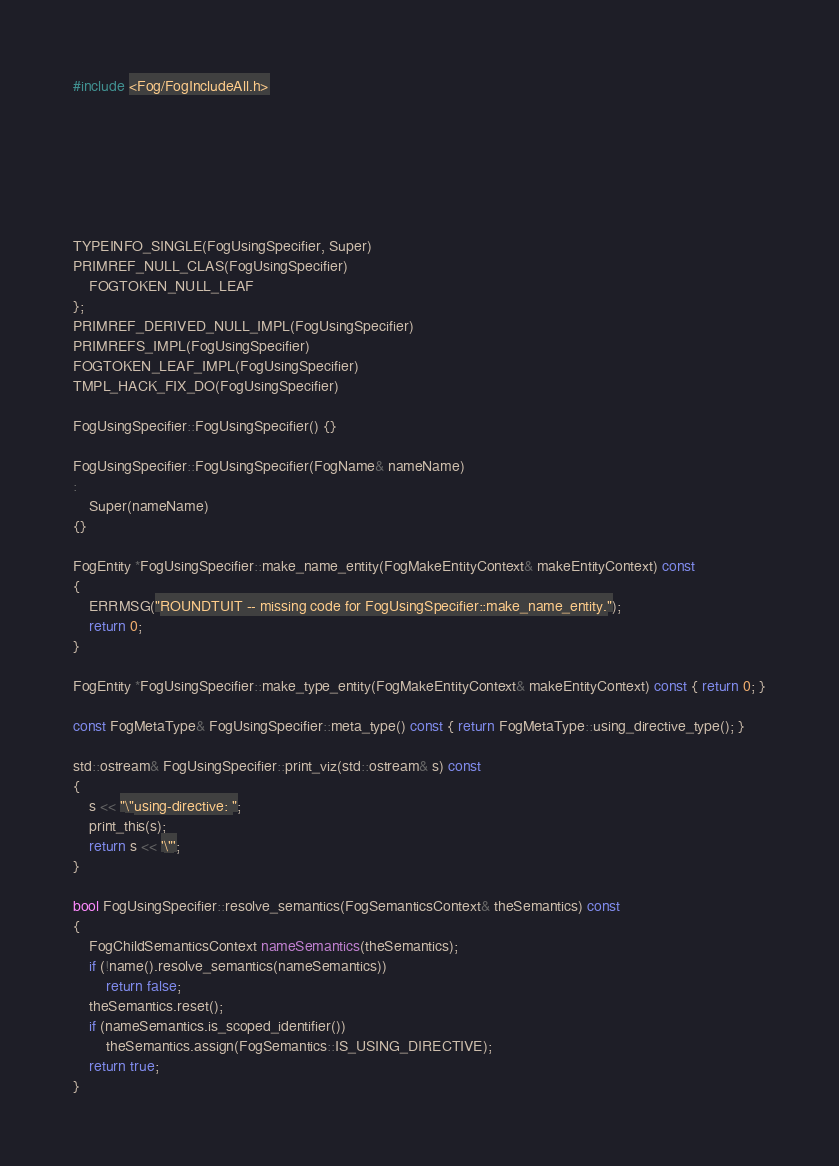Convert code to text. <code><loc_0><loc_0><loc_500><loc_500><_C++_>#include <Fog/FogIncludeAll.h>







TYPEINFO_SINGLE(FogUsingSpecifier, Super)
PRIMREF_NULL_CLAS(FogUsingSpecifier)
    FOGTOKEN_NULL_LEAF
};
PRIMREF_DERIVED_NULL_IMPL(FogUsingSpecifier)
PRIMREFS_IMPL(FogUsingSpecifier)
FOGTOKEN_LEAF_IMPL(FogUsingSpecifier)
TMPL_HACK_FIX_DO(FogUsingSpecifier)

FogUsingSpecifier::FogUsingSpecifier() {}

FogUsingSpecifier::FogUsingSpecifier(FogName& nameName)
:
    Super(nameName)
{}

FogEntity *FogUsingSpecifier::make_name_entity(FogMakeEntityContext& makeEntityContext) const
{
    ERRMSG("ROUNDTUIT -- missing code for FogUsingSpecifier::make_name_entity.");
    return 0;
}

FogEntity *FogUsingSpecifier::make_type_entity(FogMakeEntityContext& makeEntityContext) const { return 0; }

const FogMetaType& FogUsingSpecifier::meta_type() const { return FogMetaType::using_directive_type(); }

std::ostream& FogUsingSpecifier::print_viz(std::ostream& s) const
{
    s << "\"using-directive: ";
    print_this(s);
    return s << '\"';
}

bool FogUsingSpecifier::resolve_semantics(FogSemanticsContext& theSemantics) const
{
    FogChildSemanticsContext nameSemantics(theSemantics);
    if (!name().resolve_semantics(nameSemantics))
        return false;
    theSemantics.reset();
    if (nameSemantics.is_scoped_identifier())
        theSemantics.assign(FogSemantics::IS_USING_DIRECTIVE);
    return true;
}
</code> 